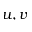<formula> <loc_0><loc_0><loc_500><loc_500>u , v</formula> 